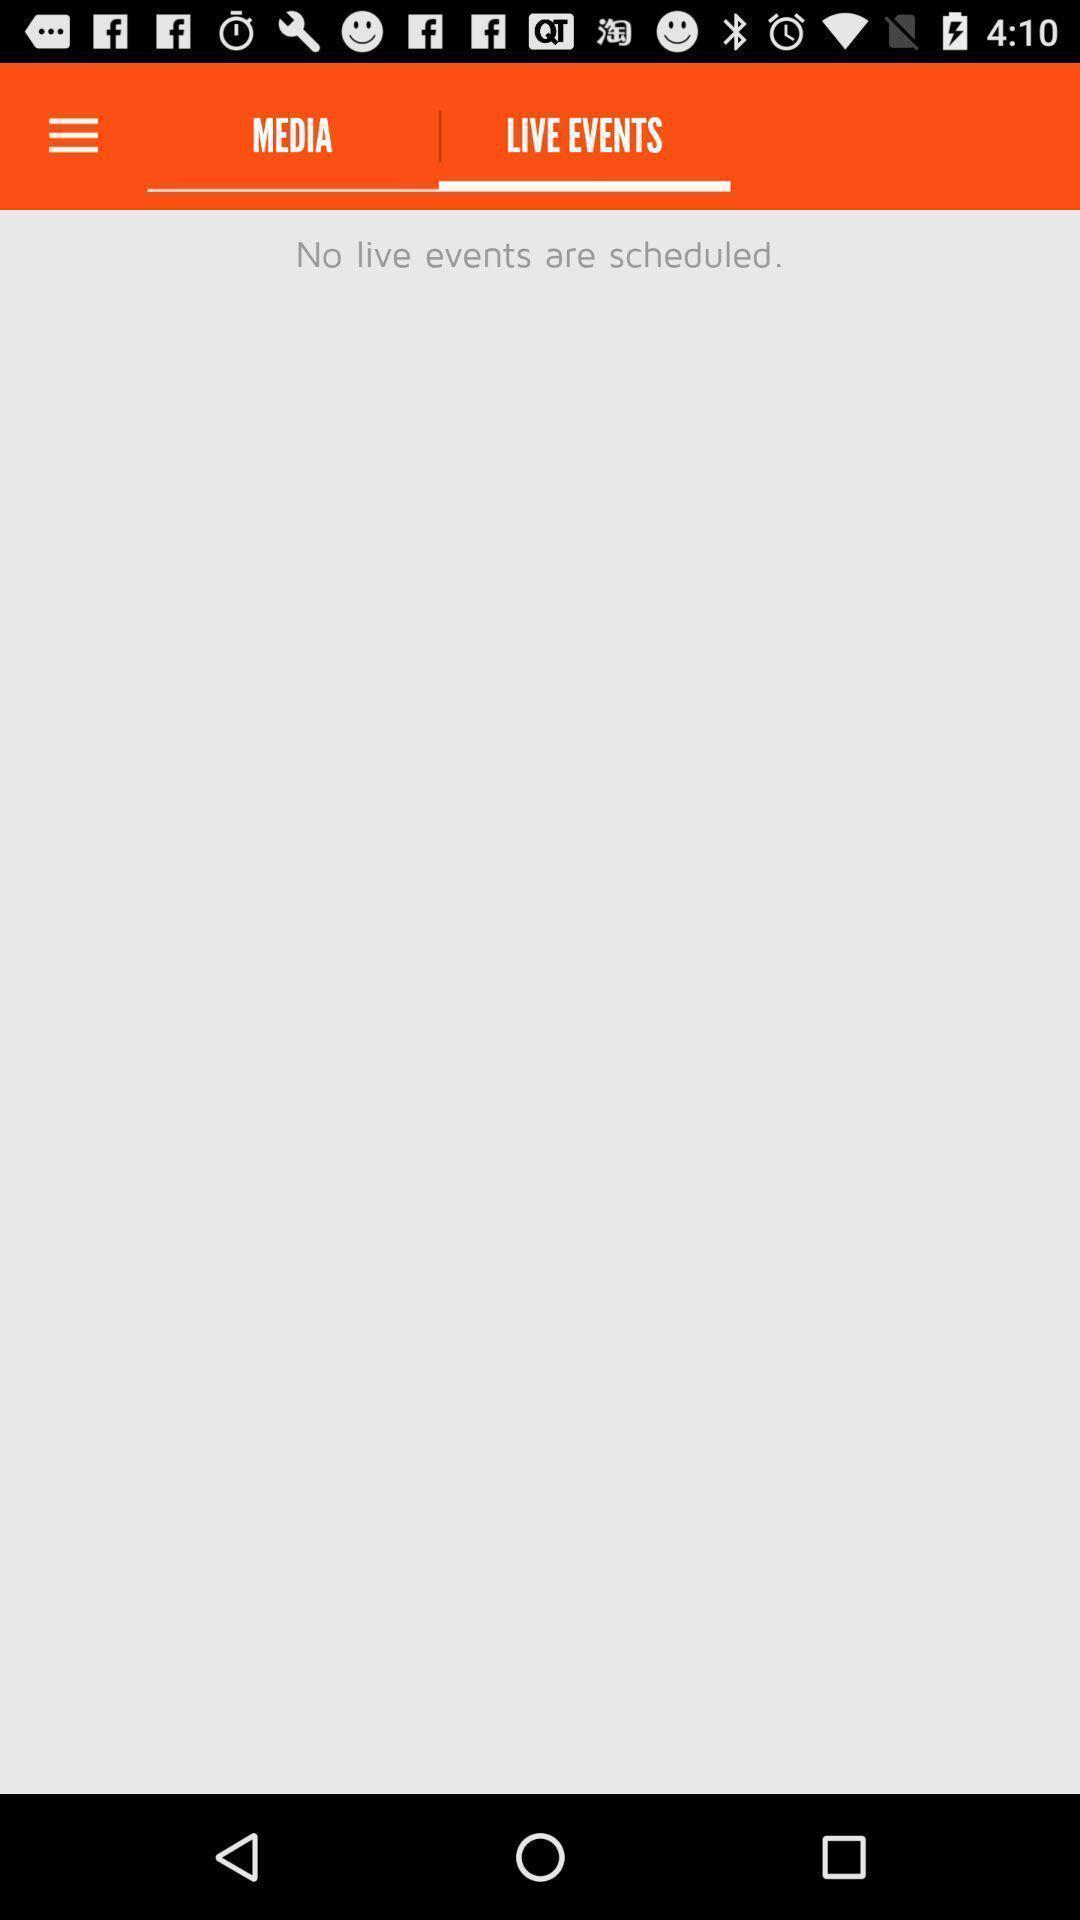Summarize the main components in this picture. Page displaying empty live events. 